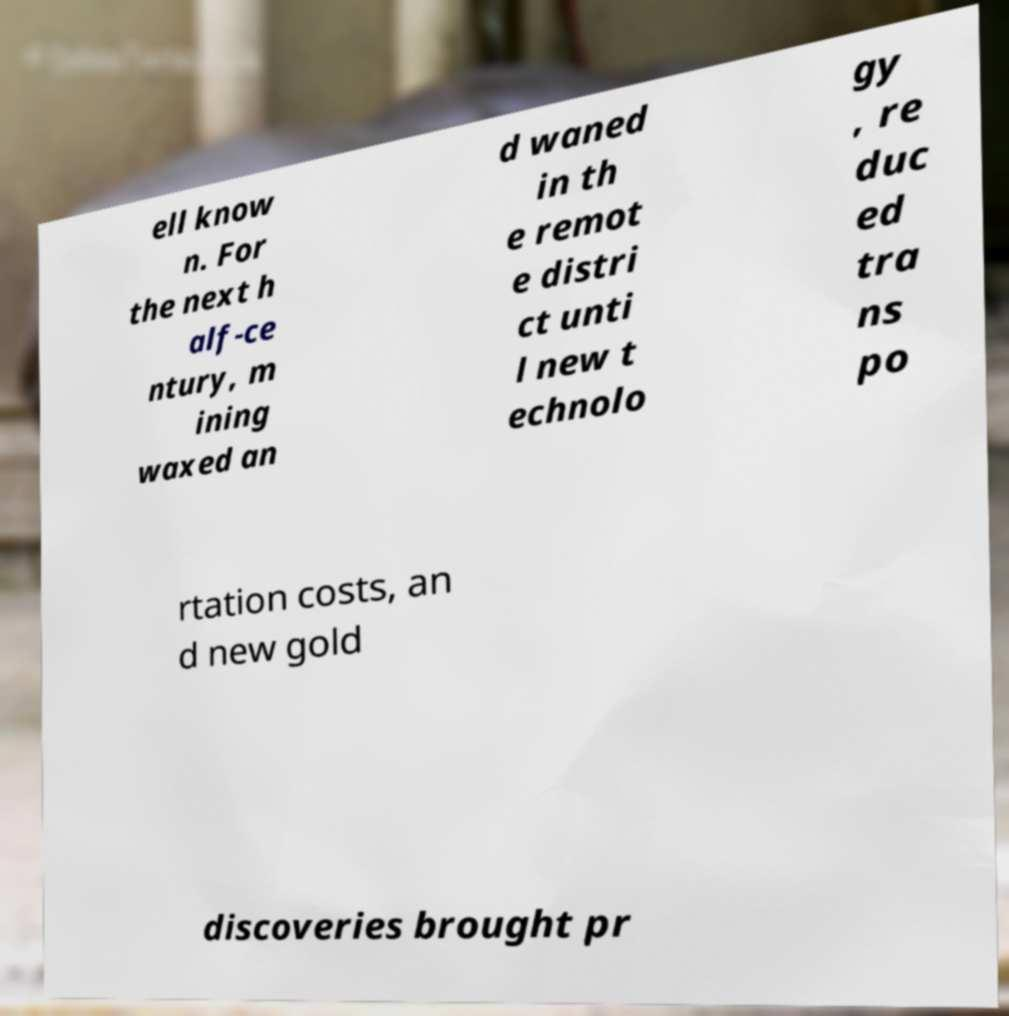Could you assist in decoding the text presented in this image and type it out clearly? ell know n. For the next h alf-ce ntury, m ining waxed an d waned in th e remot e distri ct unti l new t echnolo gy , re duc ed tra ns po rtation costs, an d new gold discoveries brought pr 